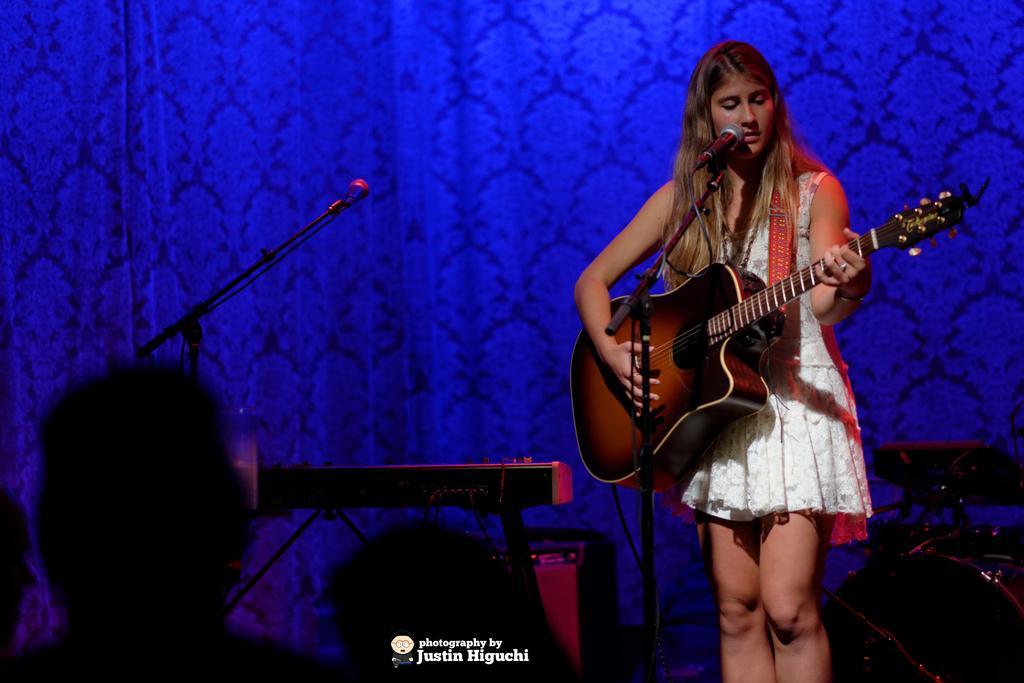Could you give a brief overview of what you see in this image? There is a woman standing on the right side. She is holding a guitar in her hand and she is singing on a microphone. Here we can see a piano on the left side. 